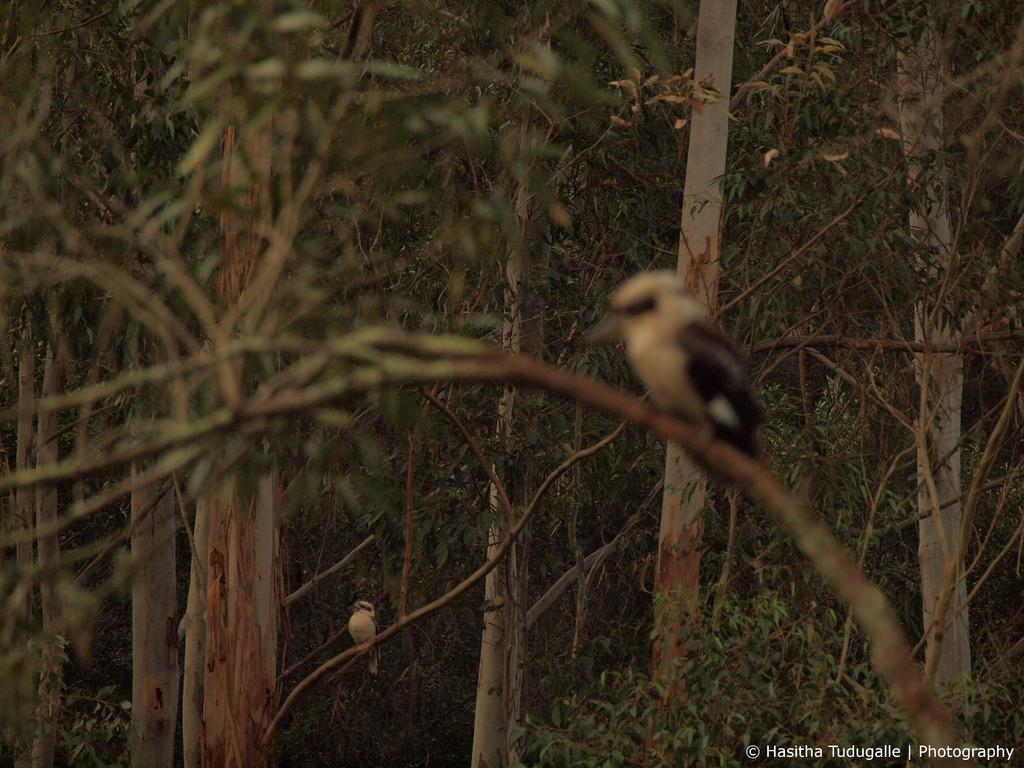What can be seen in the foreground of the picture? In the foreground of the picture, there are leaves, stems, a branch, and a bird. Can you describe the background of the picture? In the background of the picture, there are trees, another bird, and plants. Is there any text present in the image? Yes, there is text in the bottom right corner of the picture. What type of haircut does the person in the picture have? There is no person present in the image, so it is not possible to determine their haircut. On which side of the image is the person located? There is no person present in the image, so it is not possible to determine their location within the image. 